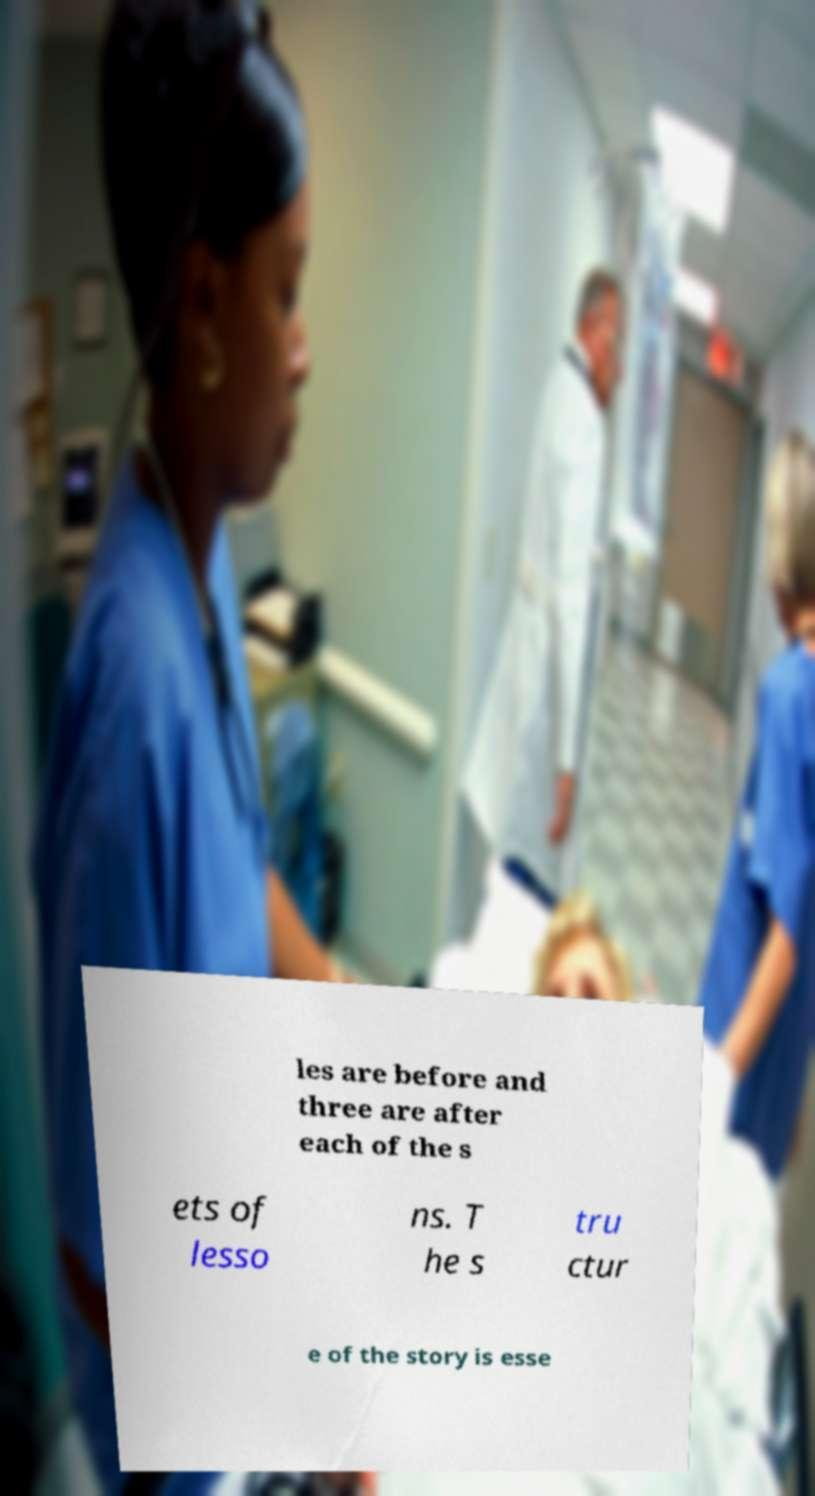Could you assist in decoding the text presented in this image and type it out clearly? les are before and three are after each of the s ets of lesso ns. T he s tru ctur e of the story is esse 